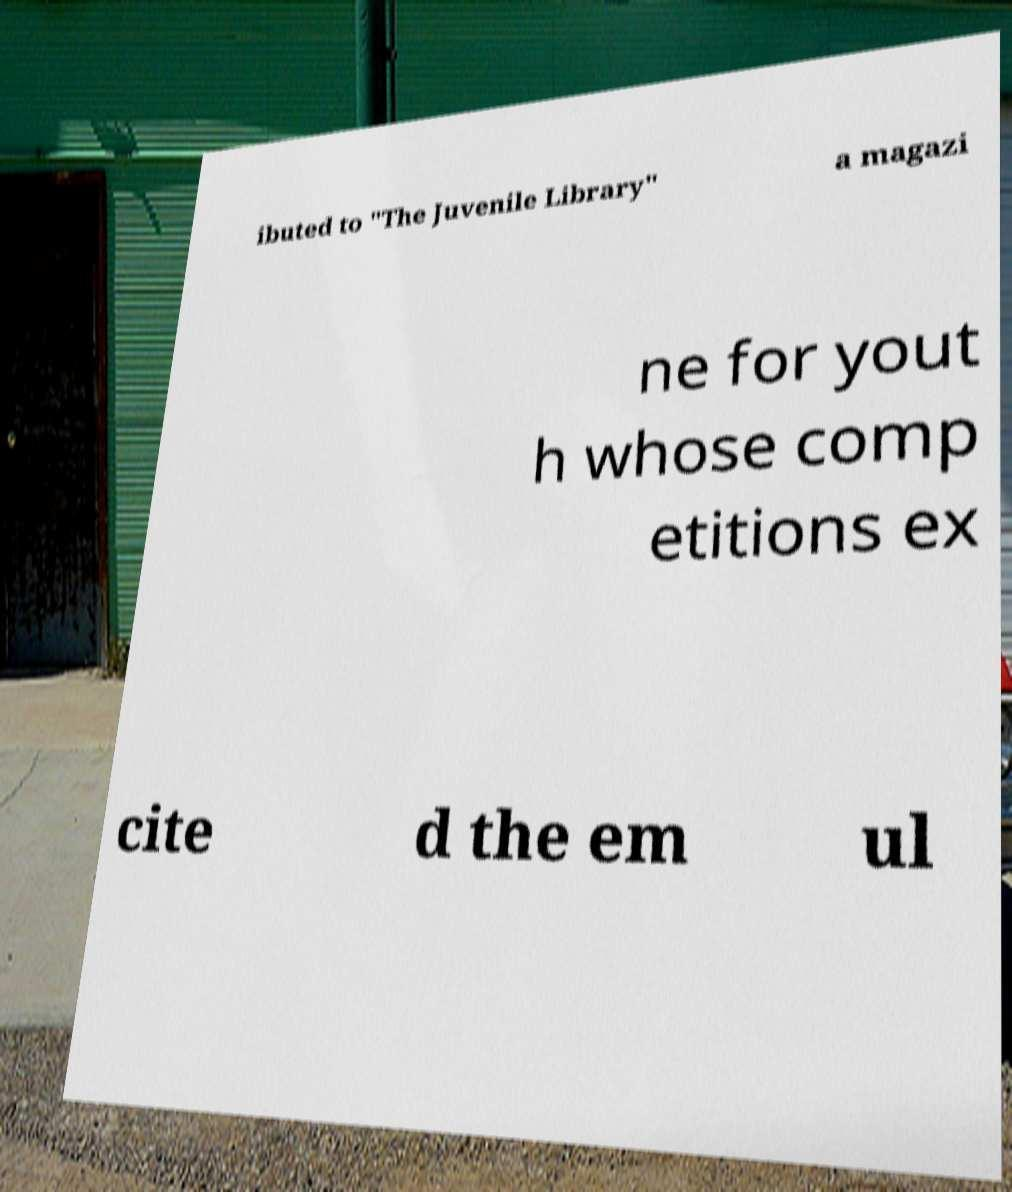There's text embedded in this image that I need extracted. Can you transcribe it verbatim? ibuted to "The Juvenile Library" a magazi ne for yout h whose comp etitions ex cite d the em ul 